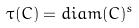Convert formula to latex. <formula><loc_0><loc_0><loc_500><loc_500>\tau ( C ) = d i a m ( C ) ^ { s }</formula> 